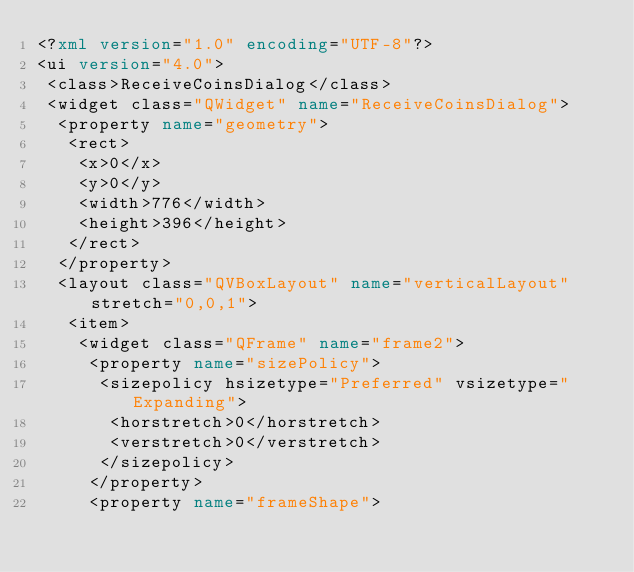<code> <loc_0><loc_0><loc_500><loc_500><_XML_><?xml version="1.0" encoding="UTF-8"?>
<ui version="4.0">
 <class>ReceiveCoinsDialog</class>
 <widget class="QWidget" name="ReceiveCoinsDialog">
  <property name="geometry">
   <rect>
    <x>0</x>
    <y>0</y>
    <width>776</width>
    <height>396</height>
   </rect>
  </property>
  <layout class="QVBoxLayout" name="verticalLayout" stretch="0,0,1">
   <item>
    <widget class="QFrame" name="frame2">
     <property name="sizePolicy">
      <sizepolicy hsizetype="Preferred" vsizetype="Expanding">
       <horstretch>0</horstretch>
       <verstretch>0</verstretch>
      </sizepolicy>
     </property>
     <property name="frameShape"></code> 